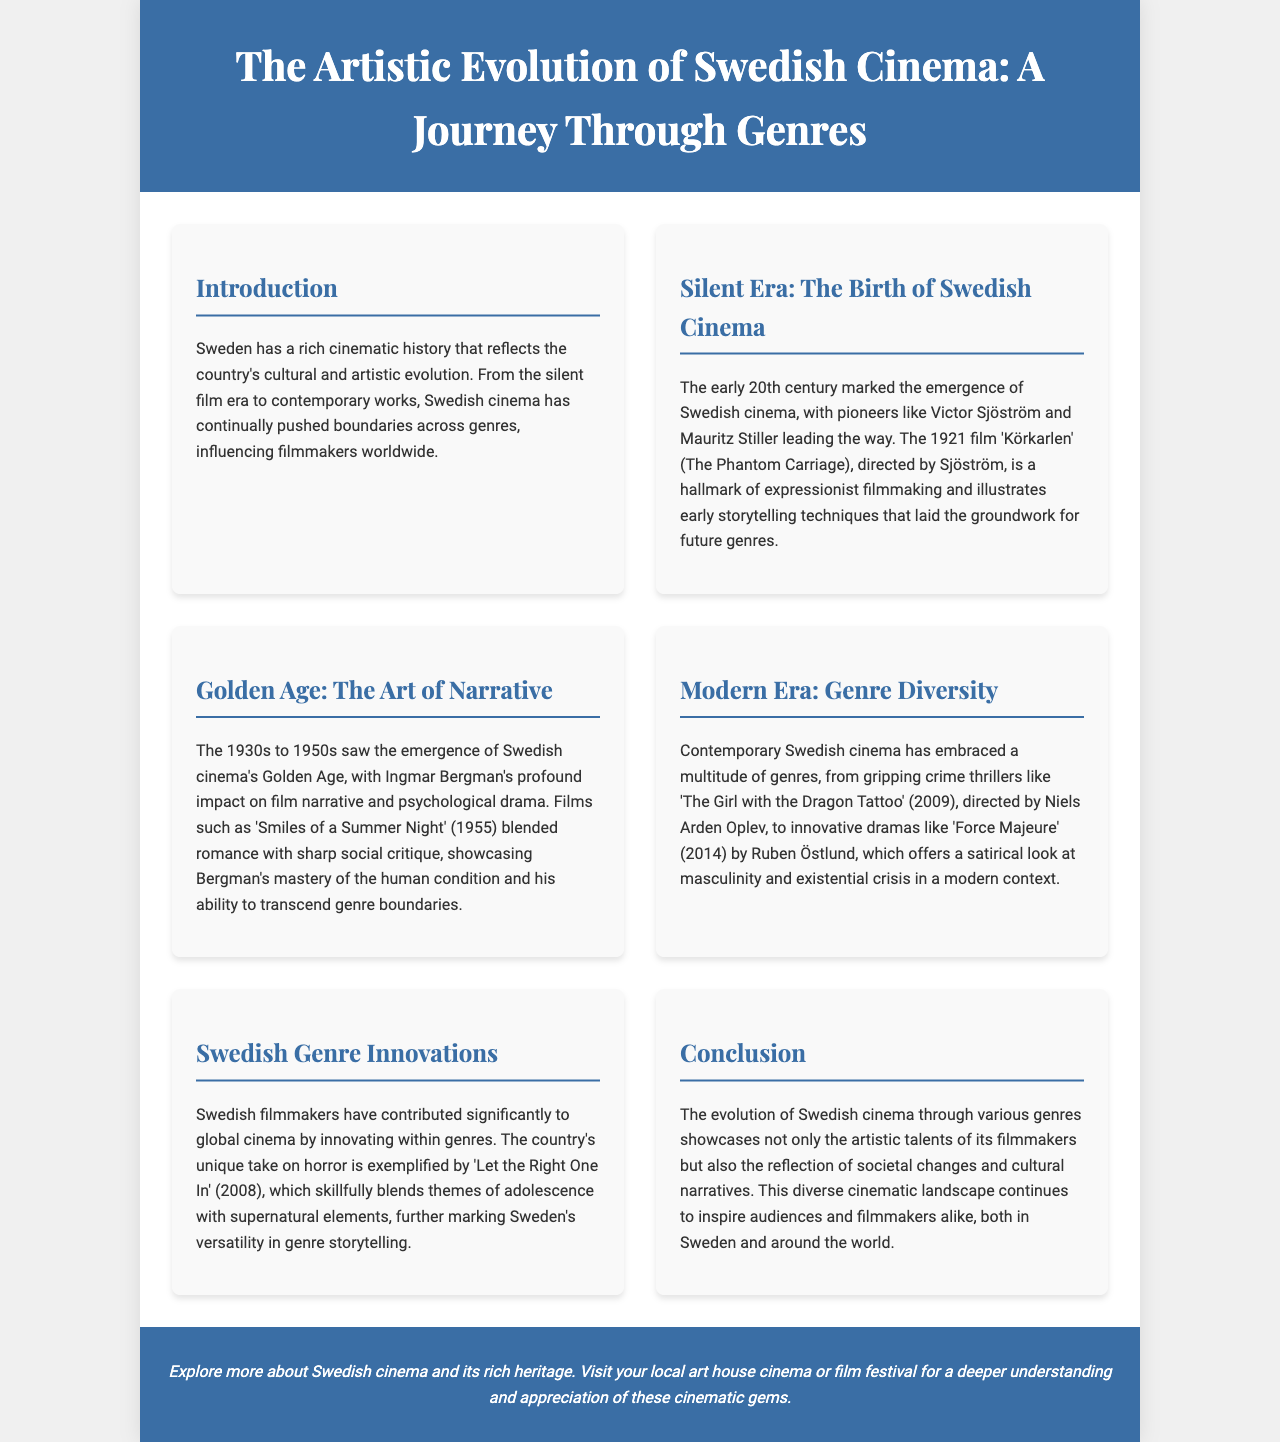What is the title of the brochure? The title of the brochure, as mentioned in the header, highlights its focus on the evolution of Swedish cinema.
Answer: The Artistic Evolution of Swedish Cinema: A Journey Through Genres Who directed the film 'Körkarlen'? The document states that 'Körkarlen' was directed by Victor Sjöström, a pioneer of Swedish cinema.
Answer: Victor Sjöström In which era did Ingmar Bergman significantly impact film narrative? The brochure identifies the 1930s to 1950s as the time when Bergman had a profound influence on Swedish cinema's storytelling.
Answer: 1930s to 1950s What genre did 'Let the Right One In' represent? The document describes 'Let the Right One In' in the context of its unique contributions to the horror genre.
Answer: Horror What film is associated with the theme of masculinity and existential crisis? 'Force Majeure' (2014) is highlighted for its satirical perspective on the themes of masculinity and existential issues.
Answer: Force Majeure In what year was 'The Girl with the Dragon Tattoo' released? The brochure provides the release year of 'The Girl with the Dragon Tattoo', indicating its relevance in modern Swedish cinema.
Answer: 2009 What is highlighted as a significant contribution of Swedish filmmakers? The document indicates that Swedish filmmakers have innovated within genres, showcasing their creativity in various cinematic forms.
Answer: Genre Innovations Which film is noted as a hallmark of expressionist filmmaking? The brochure points out 'Körkarlen' as a key example of expressionist cinema from the early 20th century.
Answer: Körkarlen What aspect of Swedish cinema does the conclusion emphasize? The conclusion emphasizes the reflection of societal changes and cultural narratives through the evolution of Swedish cinema.
Answer: Societal changes and cultural narratives 